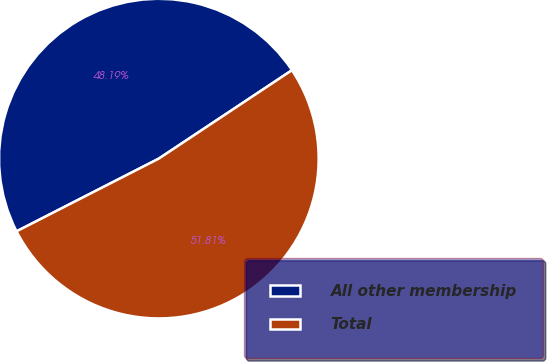<chart> <loc_0><loc_0><loc_500><loc_500><pie_chart><fcel>All other membership<fcel>Total<nl><fcel>48.19%<fcel>51.81%<nl></chart> 